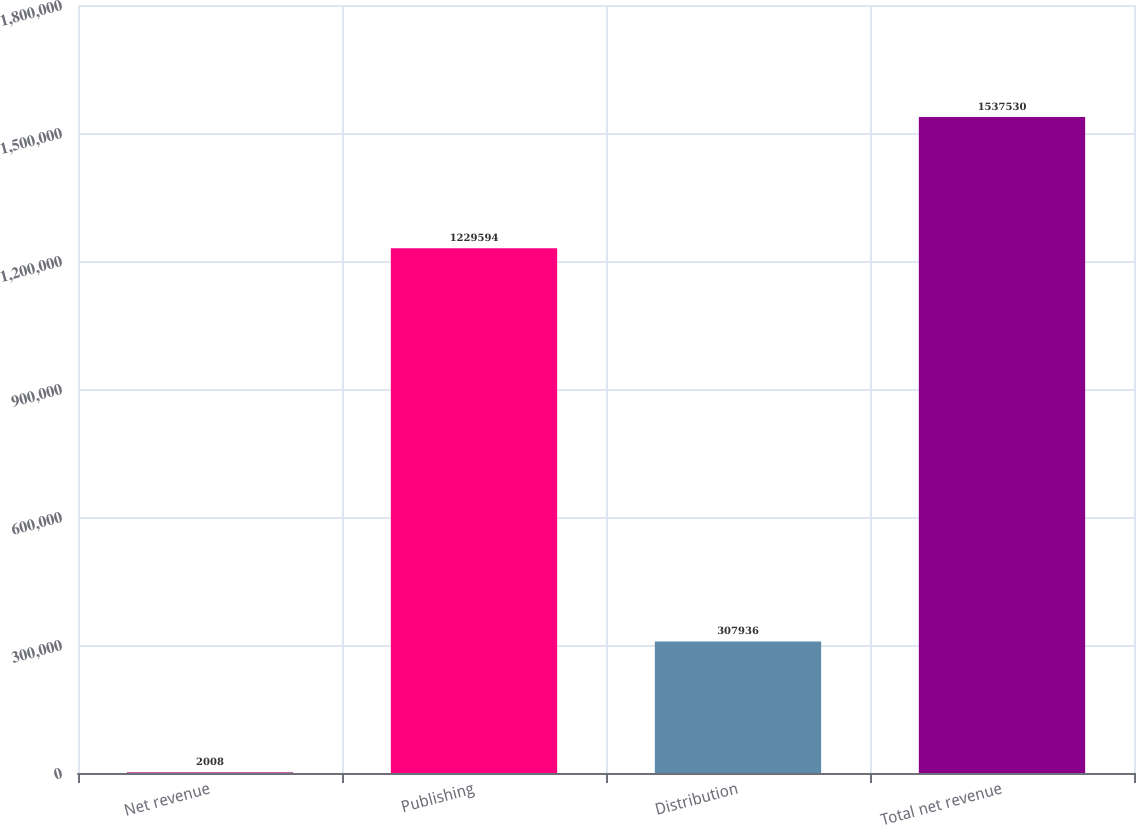<chart> <loc_0><loc_0><loc_500><loc_500><bar_chart><fcel>Net revenue<fcel>Publishing<fcel>Distribution<fcel>Total net revenue<nl><fcel>2008<fcel>1.22959e+06<fcel>307936<fcel>1.53753e+06<nl></chart> 